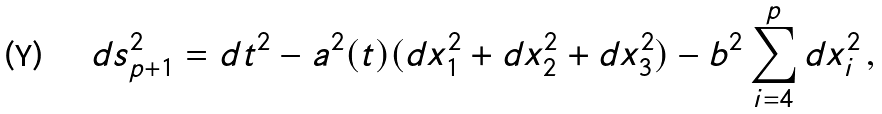<formula> <loc_0><loc_0><loc_500><loc_500>d s _ { p + 1 } ^ { 2 } = d t ^ { 2 } - a ^ { 2 } ( t ) ( d x _ { 1 } ^ { 2 } + d x _ { 2 } ^ { 2 } + d x _ { 3 } ^ { 2 } ) - b ^ { 2 } \sum _ { i = 4 } ^ { p } d x _ { i } ^ { 2 } \, ,</formula> 